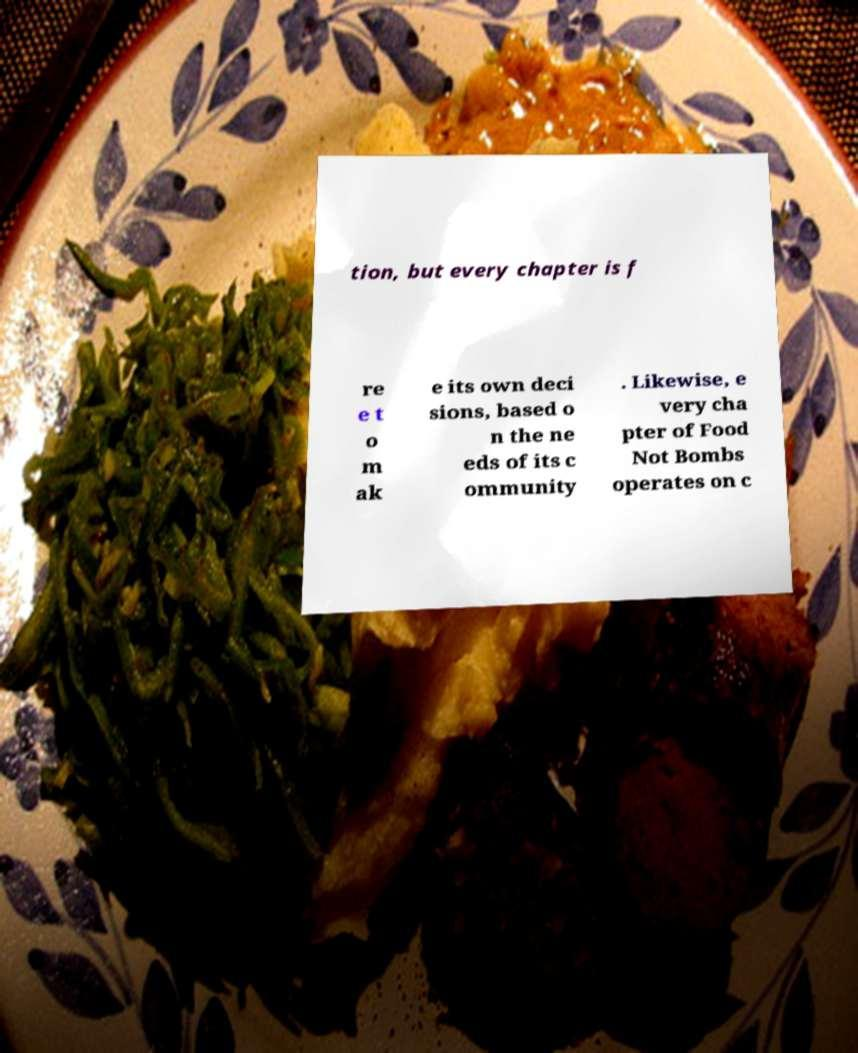Could you assist in decoding the text presented in this image and type it out clearly? tion, but every chapter is f re e t o m ak e its own deci sions, based o n the ne eds of its c ommunity . Likewise, e very cha pter of Food Not Bombs operates on c 